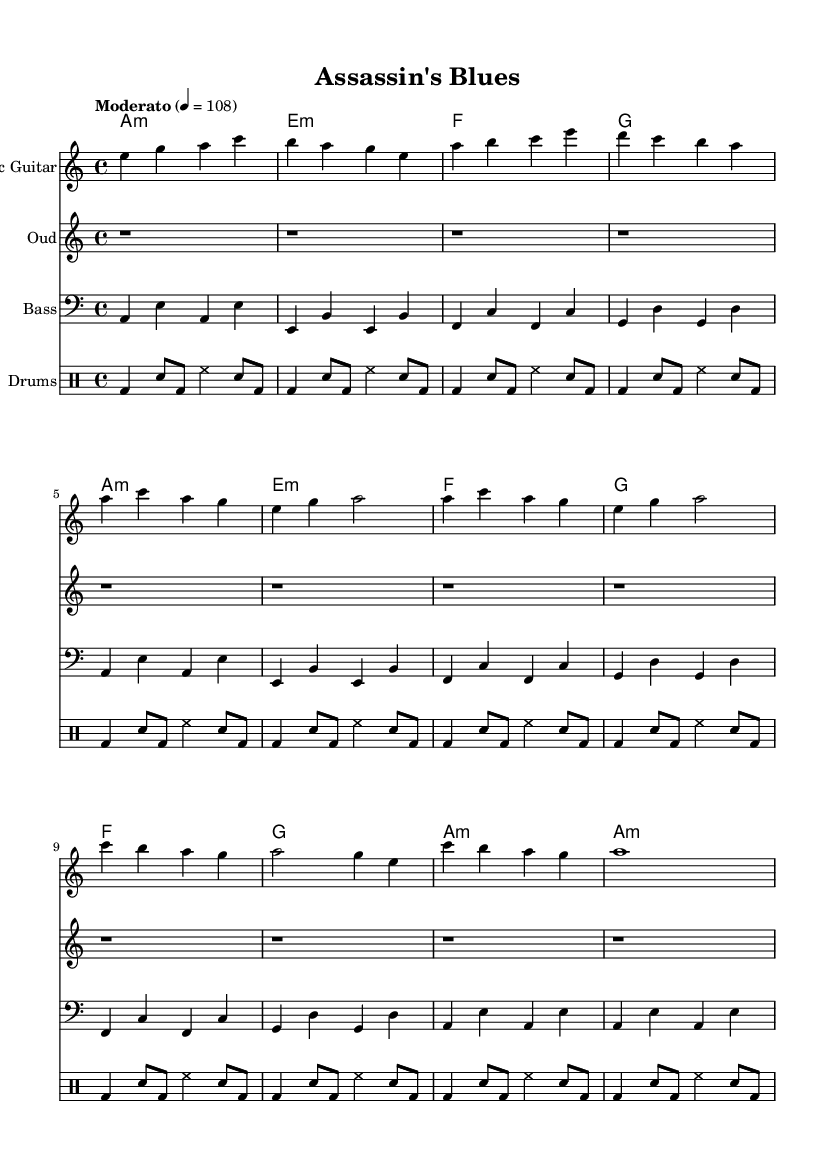What is the key signature of this music? The key signature is indicated at the beginning of the staff, showing there are no sharps or flats, which corresponds to A minor.
Answer: A minor What is the time signature of this music? The time signature is shown at the start of the score as 4/4, meaning there are four beats per measure and the quarter note gets one beat.
Answer: 4/4 What is the tempo marking of this music? The tempo marking is located above the staff, indicating a "Moderato" pace, with a beats-per-minute (BPM) value of 108.
Answer: Moderato 4 = 108 How many measures are in the chorus section? By counting the measures in the chorus part, which is typically sectioned out in the sheet music, we note there are four measures of music.
Answer: 4 What are the chord names for the verse section? The chord names can be observed in the chord names part of the sheet music corresponding to the verse: A minor, E minor, F, and G.
Answer: A minor, E minor, F, G Which instruments are included in this piece? The instruments are listed in their respective sections: Electric Guitar, Oud, Bass, and Drums.
Answer: Electric Guitar, Oud, Bass, Drums What rhythmic figure is prominently used in the drums section? The drums part consistently includes a bass drum and snare pattern, creating a typical blues shuffle rhythm throughout the piece.
Answer: Bass drum and snare pattern 